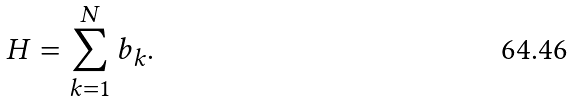Convert formula to latex. <formula><loc_0><loc_0><loc_500><loc_500>H = \sum _ { k = 1 } ^ { N } b _ { k } .</formula> 